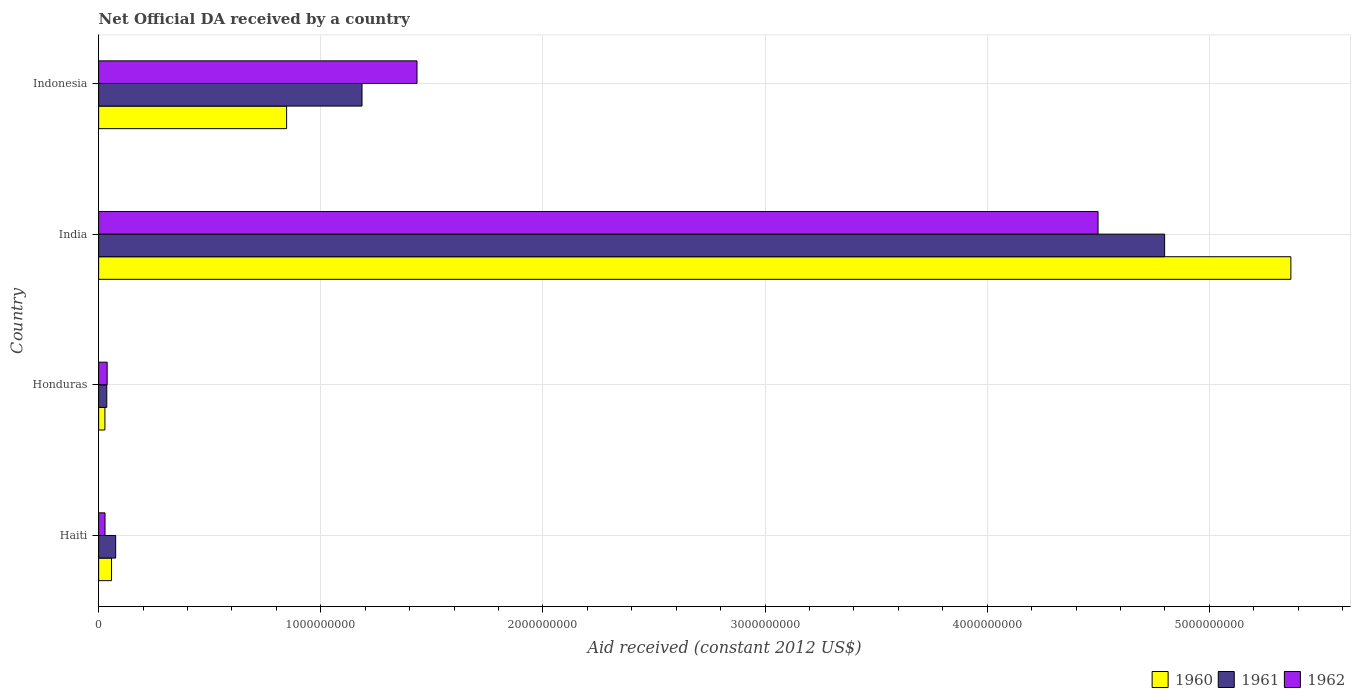How many different coloured bars are there?
Offer a terse response. 3. How many groups of bars are there?
Your response must be concise. 4. Are the number of bars on each tick of the Y-axis equal?
Offer a terse response. Yes. How many bars are there on the 4th tick from the bottom?
Give a very brief answer. 3. What is the label of the 2nd group of bars from the top?
Ensure brevity in your answer.  India. In how many cases, is the number of bars for a given country not equal to the number of legend labels?
Offer a terse response. 0. What is the net official development assistance aid received in 1960 in Haiti?
Your answer should be compact. 5.80e+07. Across all countries, what is the maximum net official development assistance aid received in 1961?
Your answer should be very brief. 4.80e+09. Across all countries, what is the minimum net official development assistance aid received in 1962?
Ensure brevity in your answer.  2.88e+07. In which country was the net official development assistance aid received in 1960 minimum?
Provide a succinct answer. Honduras. What is the total net official development assistance aid received in 1962 in the graph?
Keep it short and to the point. 6.00e+09. What is the difference between the net official development assistance aid received in 1962 in Haiti and that in India?
Keep it short and to the point. -4.47e+09. What is the difference between the net official development assistance aid received in 1961 in India and the net official development assistance aid received in 1962 in Honduras?
Provide a succinct answer. 4.76e+09. What is the average net official development assistance aid received in 1961 per country?
Your answer should be compact. 1.52e+09. What is the difference between the net official development assistance aid received in 1961 and net official development assistance aid received in 1960 in Indonesia?
Ensure brevity in your answer.  3.39e+08. In how many countries, is the net official development assistance aid received in 1962 greater than 400000000 US$?
Give a very brief answer. 2. What is the ratio of the net official development assistance aid received in 1962 in Honduras to that in Indonesia?
Provide a short and direct response. 0.03. Is the net official development assistance aid received in 1961 in Haiti less than that in Honduras?
Ensure brevity in your answer.  No. What is the difference between the highest and the second highest net official development assistance aid received in 1961?
Offer a terse response. 3.61e+09. What is the difference between the highest and the lowest net official development assistance aid received in 1960?
Provide a succinct answer. 5.34e+09. Is the sum of the net official development assistance aid received in 1961 in Honduras and Indonesia greater than the maximum net official development assistance aid received in 1962 across all countries?
Make the answer very short. No. What does the 3rd bar from the top in Indonesia represents?
Give a very brief answer. 1960. What is the difference between two consecutive major ticks on the X-axis?
Keep it short and to the point. 1.00e+09. Does the graph contain any zero values?
Keep it short and to the point. No. Does the graph contain grids?
Provide a short and direct response. Yes. Where does the legend appear in the graph?
Your answer should be very brief. Bottom right. How many legend labels are there?
Keep it short and to the point. 3. What is the title of the graph?
Your response must be concise. Net Official DA received by a country. What is the label or title of the X-axis?
Offer a terse response. Aid received (constant 2012 US$). What is the label or title of the Y-axis?
Your answer should be very brief. Country. What is the Aid received (constant 2012 US$) in 1960 in Haiti?
Provide a succinct answer. 5.80e+07. What is the Aid received (constant 2012 US$) of 1961 in Haiti?
Provide a short and direct response. 7.67e+07. What is the Aid received (constant 2012 US$) in 1962 in Haiti?
Your response must be concise. 2.88e+07. What is the Aid received (constant 2012 US$) of 1960 in Honduras?
Make the answer very short. 2.82e+07. What is the Aid received (constant 2012 US$) of 1961 in Honduras?
Offer a terse response. 3.67e+07. What is the Aid received (constant 2012 US$) of 1962 in Honduras?
Make the answer very short. 3.84e+07. What is the Aid received (constant 2012 US$) in 1960 in India?
Ensure brevity in your answer.  5.37e+09. What is the Aid received (constant 2012 US$) of 1961 in India?
Your answer should be very brief. 4.80e+09. What is the Aid received (constant 2012 US$) of 1962 in India?
Provide a succinct answer. 4.50e+09. What is the Aid received (constant 2012 US$) in 1960 in Indonesia?
Give a very brief answer. 8.46e+08. What is the Aid received (constant 2012 US$) of 1961 in Indonesia?
Ensure brevity in your answer.  1.19e+09. What is the Aid received (constant 2012 US$) of 1962 in Indonesia?
Offer a terse response. 1.43e+09. Across all countries, what is the maximum Aid received (constant 2012 US$) of 1960?
Your answer should be very brief. 5.37e+09. Across all countries, what is the maximum Aid received (constant 2012 US$) of 1961?
Offer a terse response. 4.80e+09. Across all countries, what is the maximum Aid received (constant 2012 US$) of 1962?
Your answer should be very brief. 4.50e+09. Across all countries, what is the minimum Aid received (constant 2012 US$) in 1960?
Make the answer very short. 2.82e+07. Across all countries, what is the minimum Aid received (constant 2012 US$) in 1961?
Your answer should be very brief. 3.67e+07. Across all countries, what is the minimum Aid received (constant 2012 US$) in 1962?
Provide a short and direct response. 2.88e+07. What is the total Aid received (constant 2012 US$) of 1960 in the graph?
Your answer should be very brief. 6.30e+09. What is the total Aid received (constant 2012 US$) of 1961 in the graph?
Provide a succinct answer. 6.10e+09. What is the total Aid received (constant 2012 US$) in 1962 in the graph?
Ensure brevity in your answer.  6.00e+09. What is the difference between the Aid received (constant 2012 US$) in 1960 in Haiti and that in Honduras?
Ensure brevity in your answer.  2.97e+07. What is the difference between the Aid received (constant 2012 US$) of 1961 in Haiti and that in Honduras?
Your response must be concise. 4.00e+07. What is the difference between the Aid received (constant 2012 US$) of 1962 in Haiti and that in Honduras?
Provide a short and direct response. -9.61e+06. What is the difference between the Aid received (constant 2012 US$) of 1960 in Haiti and that in India?
Your answer should be very brief. -5.31e+09. What is the difference between the Aid received (constant 2012 US$) of 1961 in Haiti and that in India?
Offer a very short reply. -4.72e+09. What is the difference between the Aid received (constant 2012 US$) in 1962 in Haiti and that in India?
Your answer should be very brief. -4.47e+09. What is the difference between the Aid received (constant 2012 US$) of 1960 in Haiti and that in Indonesia?
Provide a short and direct response. -7.88e+08. What is the difference between the Aid received (constant 2012 US$) of 1961 in Haiti and that in Indonesia?
Ensure brevity in your answer.  -1.11e+09. What is the difference between the Aid received (constant 2012 US$) in 1962 in Haiti and that in Indonesia?
Offer a terse response. -1.40e+09. What is the difference between the Aid received (constant 2012 US$) of 1960 in Honduras and that in India?
Ensure brevity in your answer.  -5.34e+09. What is the difference between the Aid received (constant 2012 US$) of 1961 in Honduras and that in India?
Ensure brevity in your answer.  -4.76e+09. What is the difference between the Aid received (constant 2012 US$) of 1962 in Honduras and that in India?
Give a very brief answer. -4.46e+09. What is the difference between the Aid received (constant 2012 US$) of 1960 in Honduras and that in Indonesia?
Give a very brief answer. -8.18e+08. What is the difference between the Aid received (constant 2012 US$) in 1961 in Honduras and that in Indonesia?
Offer a very short reply. -1.15e+09. What is the difference between the Aid received (constant 2012 US$) in 1962 in Honduras and that in Indonesia?
Offer a very short reply. -1.39e+09. What is the difference between the Aid received (constant 2012 US$) in 1960 in India and that in Indonesia?
Ensure brevity in your answer.  4.52e+09. What is the difference between the Aid received (constant 2012 US$) in 1961 in India and that in Indonesia?
Your answer should be compact. 3.61e+09. What is the difference between the Aid received (constant 2012 US$) of 1962 in India and that in Indonesia?
Your answer should be very brief. 3.07e+09. What is the difference between the Aid received (constant 2012 US$) in 1960 in Haiti and the Aid received (constant 2012 US$) in 1961 in Honduras?
Your answer should be very brief. 2.13e+07. What is the difference between the Aid received (constant 2012 US$) in 1960 in Haiti and the Aid received (constant 2012 US$) in 1962 in Honduras?
Provide a succinct answer. 1.96e+07. What is the difference between the Aid received (constant 2012 US$) in 1961 in Haiti and the Aid received (constant 2012 US$) in 1962 in Honduras?
Your response must be concise. 3.83e+07. What is the difference between the Aid received (constant 2012 US$) in 1960 in Haiti and the Aid received (constant 2012 US$) in 1961 in India?
Make the answer very short. -4.74e+09. What is the difference between the Aid received (constant 2012 US$) in 1960 in Haiti and the Aid received (constant 2012 US$) in 1962 in India?
Your answer should be very brief. -4.44e+09. What is the difference between the Aid received (constant 2012 US$) of 1961 in Haiti and the Aid received (constant 2012 US$) of 1962 in India?
Provide a short and direct response. -4.42e+09. What is the difference between the Aid received (constant 2012 US$) of 1960 in Haiti and the Aid received (constant 2012 US$) of 1961 in Indonesia?
Offer a terse response. -1.13e+09. What is the difference between the Aid received (constant 2012 US$) of 1960 in Haiti and the Aid received (constant 2012 US$) of 1962 in Indonesia?
Your answer should be very brief. -1.38e+09. What is the difference between the Aid received (constant 2012 US$) of 1961 in Haiti and the Aid received (constant 2012 US$) of 1962 in Indonesia?
Make the answer very short. -1.36e+09. What is the difference between the Aid received (constant 2012 US$) of 1960 in Honduras and the Aid received (constant 2012 US$) of 1961 in India?
Provide a succinct answer. -4.77e+09. What is the difference between the Aid received (constant 2012 US$) in 1960 in Honduras and the Aid received (constant 2012 US$) in 1962 in India?
Give a very brief answer. -4.47e+09. What is the difference between the Aid received (constant 2012 US$) in 1961 in Honduras and the Aid received (constant 2012 US$) in 1962 in India?
Ensure brevity in your answer.  -4.46e+09. What is the difference between the Aid received (constant 2012 US$) of 1960 in Honduras and the Aid received (constant 2012 US$) of 1961 in Indonesia?
Make the answer very short. -1.16e+09. What is the difference between the Aid received (constant 2012 US$) of 1960 in Honduras and the Aid received (constant 2012 US$) of 1962 in Indonesia?
Your answer should be compact. -1.40e+09. What is the difference between the Aid received (constant 2012 US$) in 1961 in Honduras and the Aid received (constant 2012 US$) in 1962 in Indonesia?
Your answer should be compact. -1.40e+09. What is the difference between the Aid received (constant 2012 US$) in 1960 in India and the Aid received (constant 2012 US$) in 1961 in Indonesia?
Your response must be concise. 4.18e+09. What is the difference between the Aid received (constant 2012 US$) in 1960 in India and the Aid received (constant 2012 US$) in 1962 in Indonesia?
Provide a succinct answer. 3.93e+09. What is the difference between the Aid received (constant 2012 US$) in 1961 in India and the Aid received (constant 2012 US$) in 1962 in Indonesia?
Your answer should be very brief. 3.37e+09. What is the average Aid received (constant 2012 US$) of 1960 per country?
Make the answer very short. 1.57e+09. What is the average Aid received (constant 2012 US$) of 1961 per country?
Ensure brevity in your answer.  1.52e+09. What is the average Aid received (constant 2012 US$) of 1962 per country?
Your answer should be compact. 1.50e+09. What is the difference between the Aid received (constant 2012 US$) in 1960 and Aid received (constant 2012 US$) in 1961 in Haiti?
Give a very brief answer. -1.87e+07. What is the difference between the Aid received (constant 2012 US$) of 1960 and Aid received (constant 2012 US$) of 1962 in Haiti?
Make the answer very short. 2.92e+07. What is the difference between the Aid received (constant 2012 US$) of 1961 and Aid received (constant 2012 US$) of 1962 in Haiti?
Provide a short and direct response. 4.79e+07. What is the difference between the Aid received (constant 2012 US$) of 1960 and Aid received (constant 2012 US$) of 1961 in Honduras?
Keep it short and to the point. -8.42e+06. What is the difference between the Aid received (constant 2012 US$) in 1960 and Aid received (constant 2012 US$) in 1962 in Honduras?
Your response must be concise. -1.01e+07. What is the difference between the Aid received (constant 2012 US$) in 1961 and Aid received (constant 2012 US$) in 1962 in Honduras?
Your answer should be compact. -1.69e+06. What is the difference between the Aid received (constant 2012 US$) of 1960 and Aid received (constant 2012 US$) of 1961 in India?
Your response must be concise. 5.68e+08. What is the difference between the Aid received (constant 2012 US$) in 1960 and Aid received (constant 2012 US$) in 1962 in India?
Provide a short and direct response. 8.68e+08. What is the difference between the Aid received (constant 2012 US$) of 1961 and Aid received (constant 2012 US$) of 1962 in India?
Keep it short and to the point. 3.00e+08. What is the difference between the Aid received (constant 2012 US$) of 1960 and Aid received (constant 2012 US$) of 1961 in Indonesia?
Offer a terse response. -3.39e+08. What is the difference between the Aid received (constant 2012 US$) of 1960 and Aid received (constant 2012 US$) of 1962 in Indonesia?
Make the answer very short. -5.87e+08. What is the difference between the Aid received (constant 2012 US$) of 1961 and Aid received (constant 2012 US$) of 1962 in Indonesia?
Your answer should be very brief. -2.48e+08. What is the ratio of the Aid received (constant 2012 US$) of 1960 in Haiti to that in Honduras?
Offer a very short reply. 2.05. What is the ratio of the Aid received (constant 2012 US$) in 1961 in Haiti to that in Honduras?
Provide a short and direct response. 2.09. What is the ratio of the Aid received (constant 2012 US$) in 1962 in Haiti to that in Honduras?
Provide a succinct answer. 0.75. What is the ratio of the Aid received (constant 2012 US$) in 1960 in Haiti to that in India?
Your answer should be compact. 0.01. What is the ratio of the Aid received (constant 2012 US$) of 1961 in Haiti to that in India?
Provide a short and direct response. 0.02. What is the ratio of the Aid received (constant 2012 US$) of 1962 in Haiti to that in India?
Provide a succinct answer. 0.01. What is the ratio of the Aid received (constant 2012 US$) in 1960 in Haiti to that in Indonesia?
Make the answer very short. 0.07. What is the ratio of the Aid received (constant 2012 US$) of 1961 in Haiti to that in Indonesia?
Provide a succinct answer. 0.06. What is the ratio of the Aid received (constant 2012 US$) of 1962 in Haiti to that in Indonesia?
Offer a terse response. 0.02. What is the ratio of the Aid received (constant 2012 US$) in 1960 in Honduras to that in India?
Your answer should be very brief. 0.01. What is the ratio of the Aid received (constant 2012 US$) in 1961 in Honduras to that in India?
Offer a terse response. 0.01. What is the ratio of the Aid received (constant 2012 US$) of 1962 in Honduras to that in India?
Keep it short and to the point. 0.01. What is the ratio of the Aid received (constant 2012 US$) of 1960 in Honduras to that in Indonesia?
Your response must be concise. 0.03. What is the ratio of the Aid received (constant 2012 US$) in 1961 in Honduras to that in Indonesia?
Give a very brief answer. 0.03. What is the ratio of the Aid received (constant 2012 US$) in 1962 in Honduras to that in Indonesia?
Keep it short and to the point. 0.03. What is the ratio of the Aid received (constant 2012 US$) of 1960 in India to that in Indonesia?
Offer a very short reply. 6.34. What is the ratio of the Aid received (constant 2012 US$) of 1961 in India to that in Indonesia?
Make the answer very short. 4.05. What is the ratio of the Aid received (constant 2012 US$) of 1962 in India to that in Indonesia?
Your answer should be very brief. 3.14. What is the difference between the highest and the second highest Aid received (constant 2012 US$) of 1960?
Your answer should be compact. 4.52e+09. What is the difference between the highest and the second highest Aid received (constant 2012 US$) of 1961?
Provide a short and direct response. 3.61e+09. What is the difference between the highest and the second highest Aid received (constant 2012 US$) of 1962?
Ensure brevity in your answer.  3.07e+09. What is the difference between the highest and the lowest Aid received (constant 2012 US$) in 1960?
Your answer should be compact. 5.34e+09. What is the difference between the highest and the lowest Aid received (constant 2012 US$) of 1961?
Offer a terse response. 4.76e+09. What is the difference between the highest and the lowest Aid received (constant 2012 US$) of 1962?
Make the answer very short. 4.47e+09. 